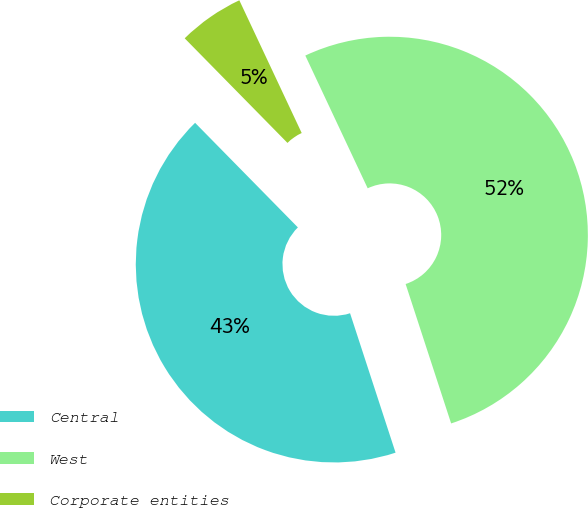Convert chart. <chart><loc_0><loc_0><loc_500><loc_500><pie_chart><fcel>Central<fcel>West<fcel>Corporate entities<nl><fcel>42.66%<fcel>51.97%<fcel>5.37%<nl></chart> 